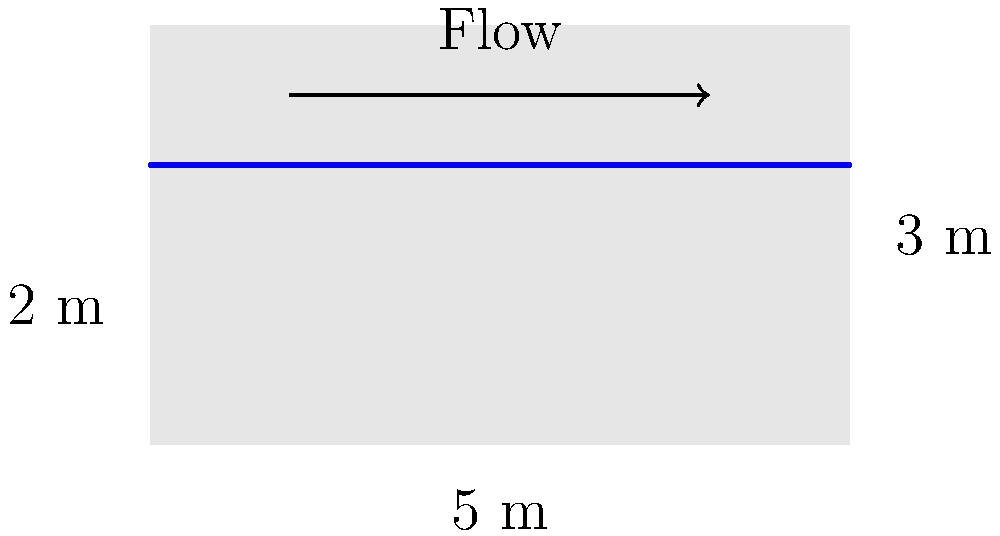In an open channel with a rectangular cross-section as shown in the diagram, the width is 5 m and the water depth is 2 m. If the flow rate in the channel is 30 m³/s, calculate the average velocity of the water flow. Assume steady, uniform flow conditions. To solve this problem, we'll follow these steps:

1) First, we need to understand the relationship between flow rate, cross-sectional area, and velocity. This is given by the continuity equation:

   $Q = A \times v$

   Where:
   $Q$ = flow rate (m³/s)
   $A$ = cross-sectional area (m²)
   $v$ = average velocity (m/s)

2) We're given the flow rate, $Q = 30$ m³/s.

3) Next, we need to calculate the cross-sectional area of the water flow:
   
   $A = \text{width} \times \text{depth}$
   $A = 5 \text{ m} \times 2 \text{ m} = 10 \text{ m}²$

4) Now we can use the continuity equation to solve for velocity:

   $v = \frac{Q}{A}$

5) Substituting our known values:

   $v = \frac{30 \text{ m}³/\text{s}}{10 \text{ m}²}$

6) Simplifying:

   $v = 3 \text{ m/s}$

Therefore, the average velocity of the water flow is 3 m/s.
Answer: 3 m/s 